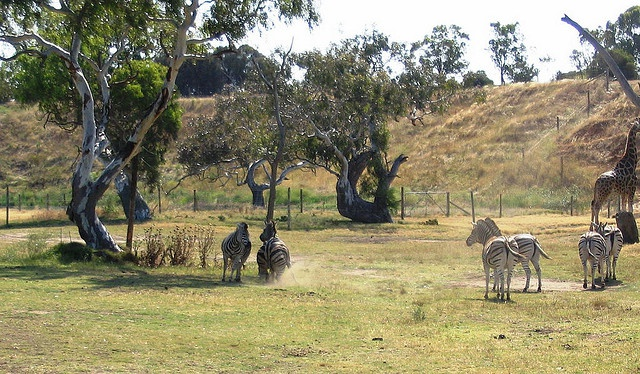Describe the objects in this image and their specific colors. I can see zebra in black, gray, and darkgray tones, giraffe in black, gray, and maroon tones, zebra in black, gray, darkgray, and ivory tones, zebra in black, gray, and tan tones, and zebra in black, gray, and darkgray tones in this image. 